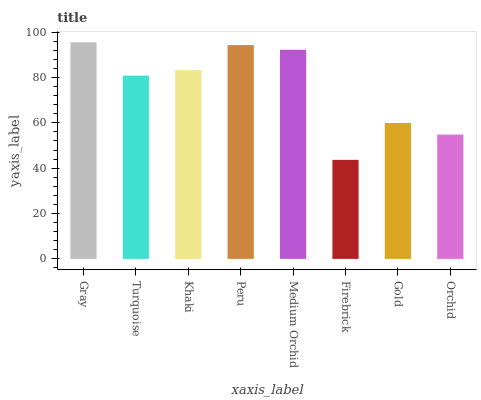Is Firebrick the minimum?
Answer yes or no. Yes. Is Gray the maximum?
Answer yes or no. Yes. Is Turquoise the minimum?
Answer yes or no. No. Is Turquoise the maximum?
Answer yes or no. No. Is Gray greater than Turquoise?
Answer yes or no. Yes. Is Turquoise less than Gray?
Answer yes or no. Yes. Is Turquoise greater than Gray?
Answer yes or no. No. Is Gray less than Turquoise?
Answer yes or no. No. Is Khaki the high median?
Answer yes or no. Yes. Is Turquoise the low median?
Answer yes or no. Yes. Is Firebrick the high median?
Answer yes or no. No. Is Gray the low median?
Answer yes or no. No. 